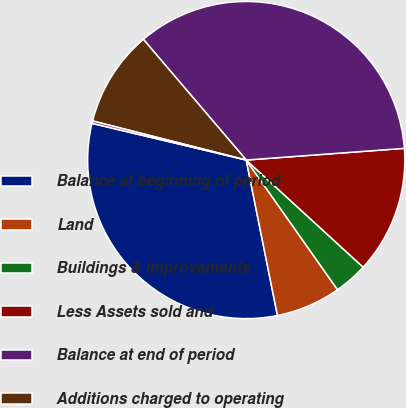Convert chart to OTSL. <chart><loc_0><loc_0><loc_500><loc_500><pie_chart><fcel>Balance at beginning of period<fcel>Land<fcel>Buildings & improvements<fcel>Less Assets sold and<fcel>Balance at end of period<fcel>Additions charged to operating<fcel>Less Accumulated depreciation<nl><fcel>31.87%<fcel>6.61%<fcel>3.43%<fcel>12.98%<fcel>35.06%<fcel>9.8%<fcel>0.25%<nl></chart> 